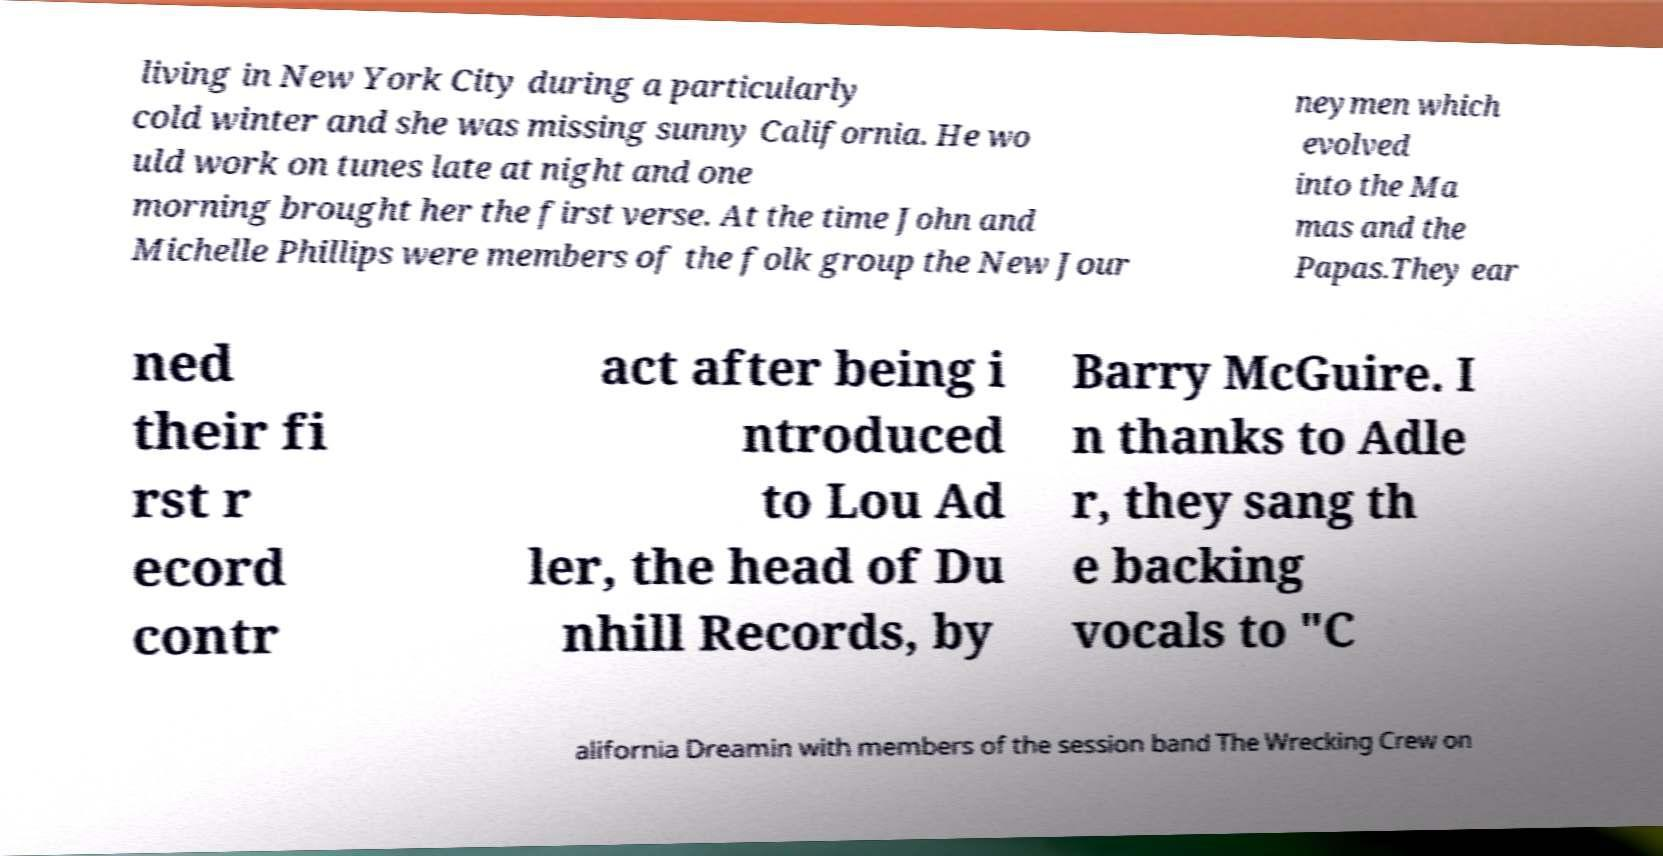I need the written content from this picture converted into text. Can you do that? living in New York City during a particularly cold winter and she was missing sunny California. He wo uld work on tunes late at night and one morning brought her the first verse. At the time John and Michelle Phillips were members of the folk group the New Jour neymen which evolved into the Ma mas and the Papas.They ear ned their fi rst r ecord contr act after being i ntroduced to Lou Ad ler, the head of Du nhill Records, by Barry McGuire. I n thanks to Adle r, they sang th e backing vocals to "C alifornia Dreamin with members of the session band The Wrecking Crew on 